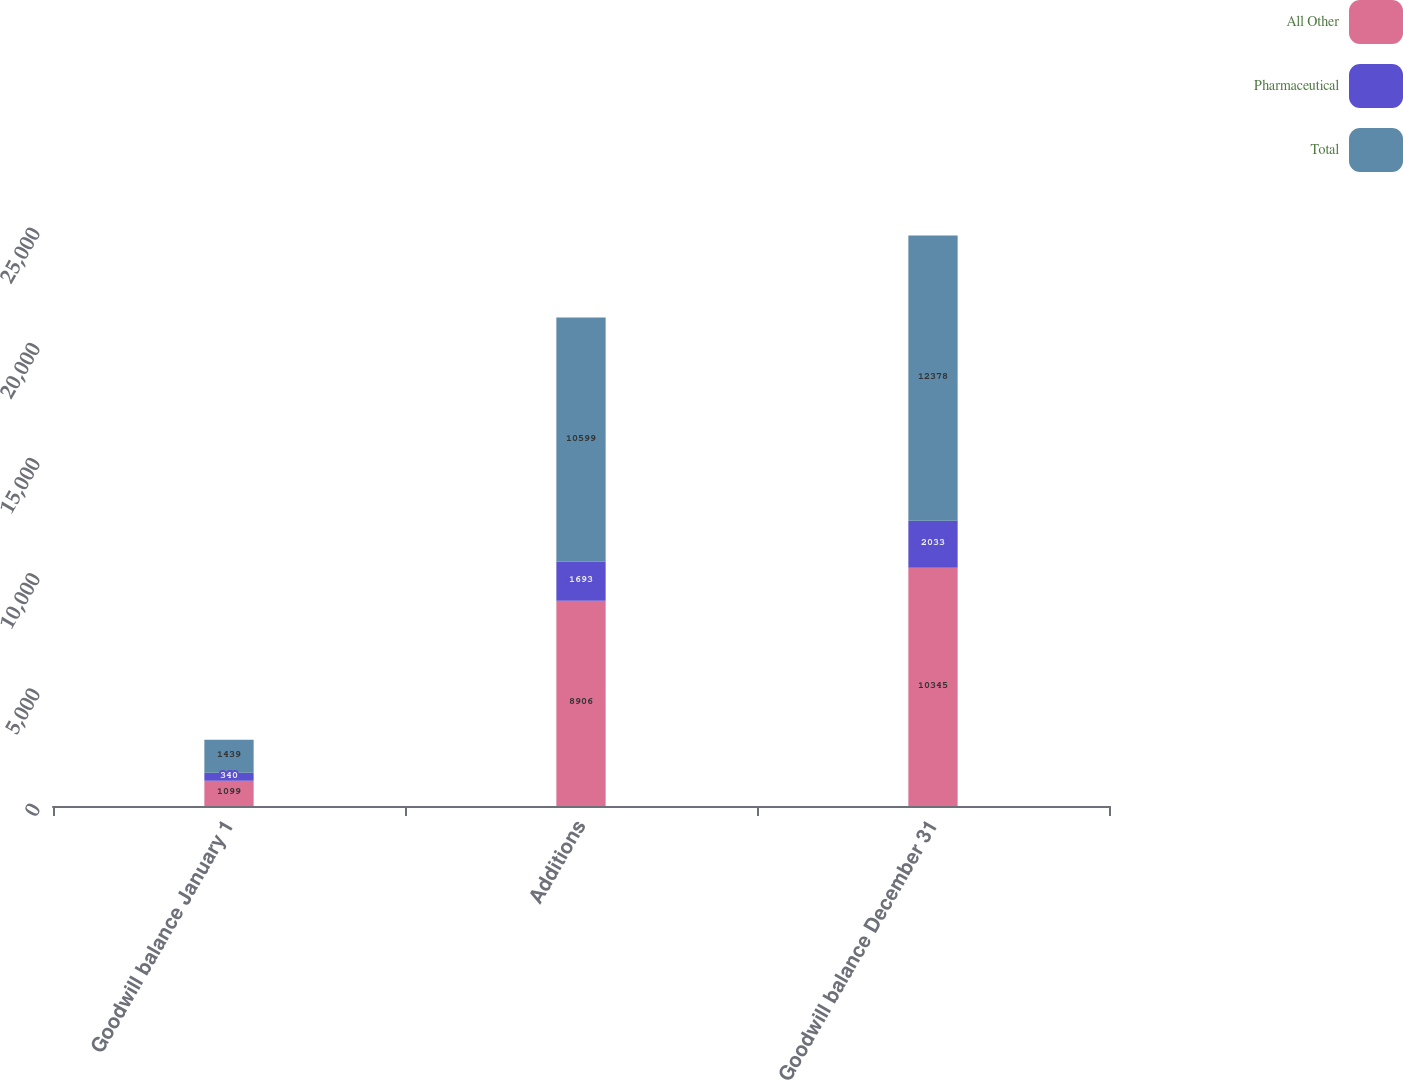<chart> <loc_0><loc_0><loc_500><loc_500><stacked_bar_chart><ecel><fcel>Goodwill balance January 1<fcel>Additions<fcel>Goodwill balance December 31<nl><fcel>All Other<fcel>1099<fcel>8906<fcel>10345<nl><fcel>Pharmaceutical<fcel>340<fcel>1693<fcel>2033<nl><fcel>Total<fcel>1439<fcel>10599<fcel>12378<nl></chart> 